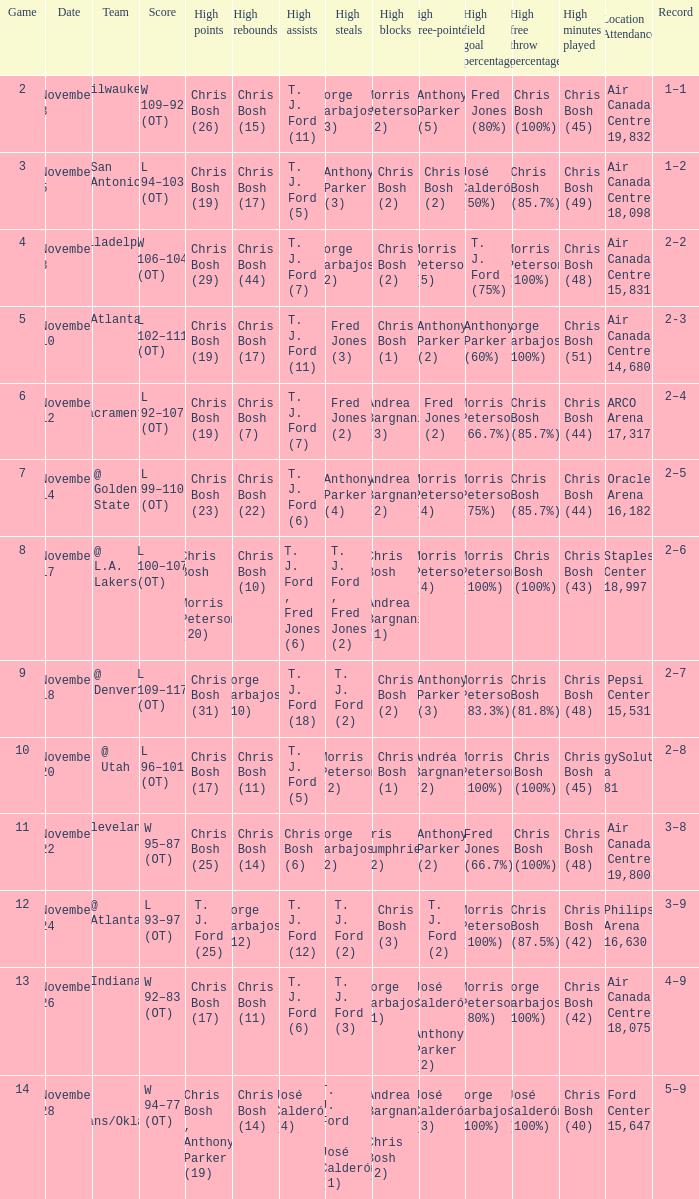Who scored the most points in game 4? Chris Bosh (29). 